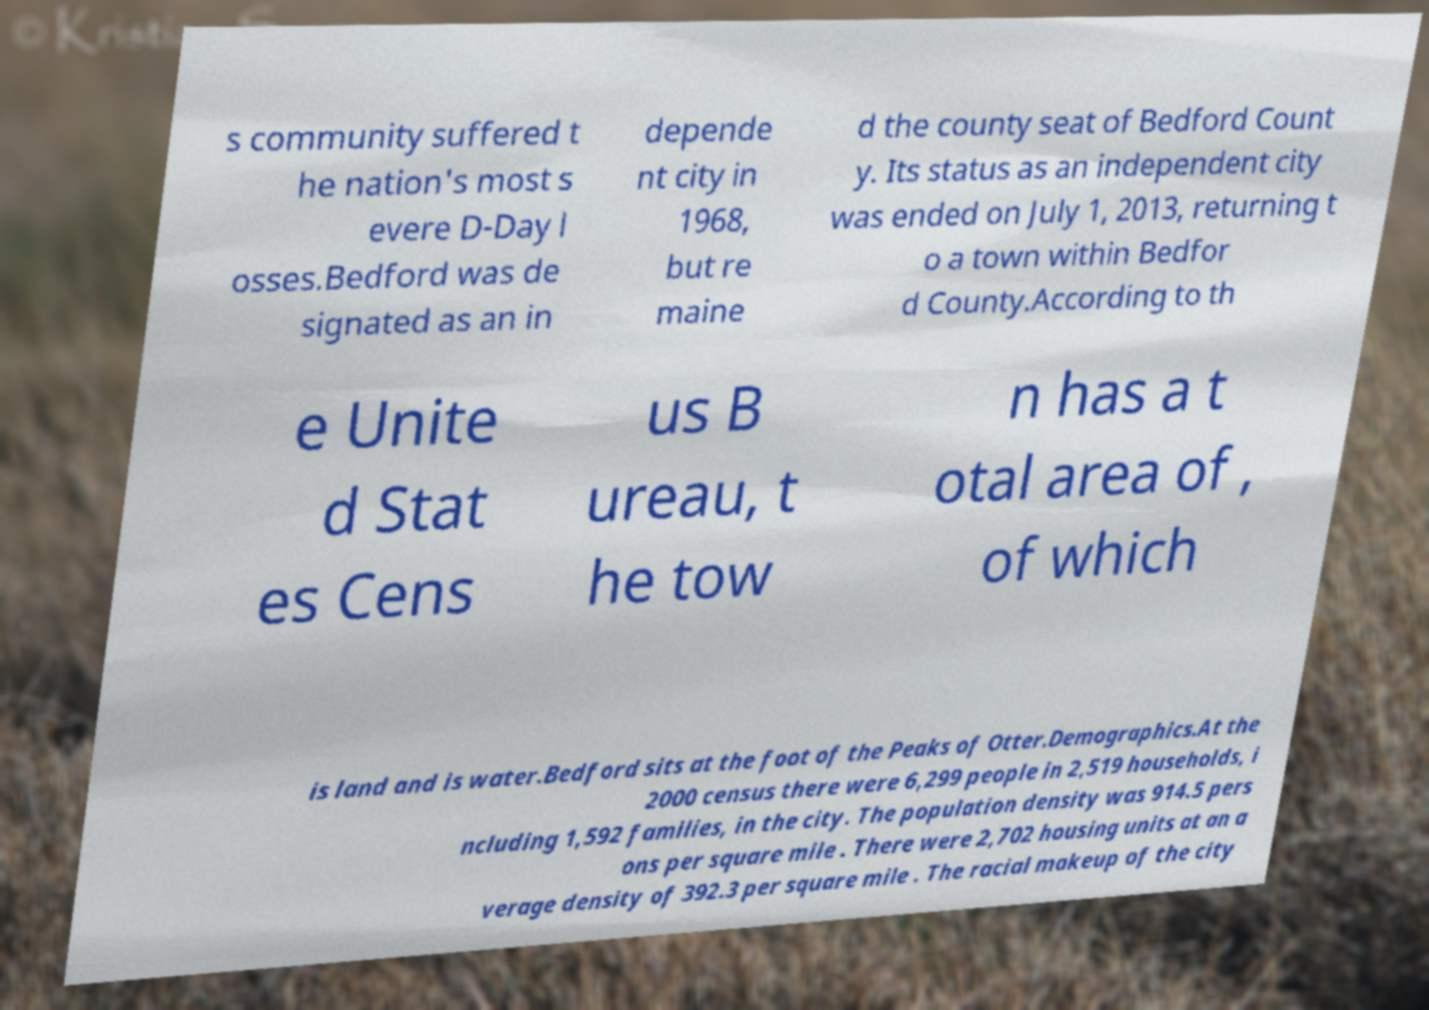I need the written content from this picture converted into text. Can you do that? s community suffered t he nation's most s evere D-Day l osses.Bedford was de signated as an in depende nt city in 1968, but re maine d the county seat of Bedford Count y. Its status as an independent city was ended on July 1, 2013, returning t o a town within Bedfor d County.According to th e Unite d Stat es Cens us B ureau, t he tow n has a t otal area of , of which is land and is water.Bedford sits at the foot of the Peaks of Otter.Demographics.At the 2000 census there were 6,299 people in 2,519 households, i ncluding 1,592 families, in the city. The population density was 914.5 pers ons per square mile . There were 2,702 housing units at an a verage density of 392.3 per square mile . The racial makeup of the city 